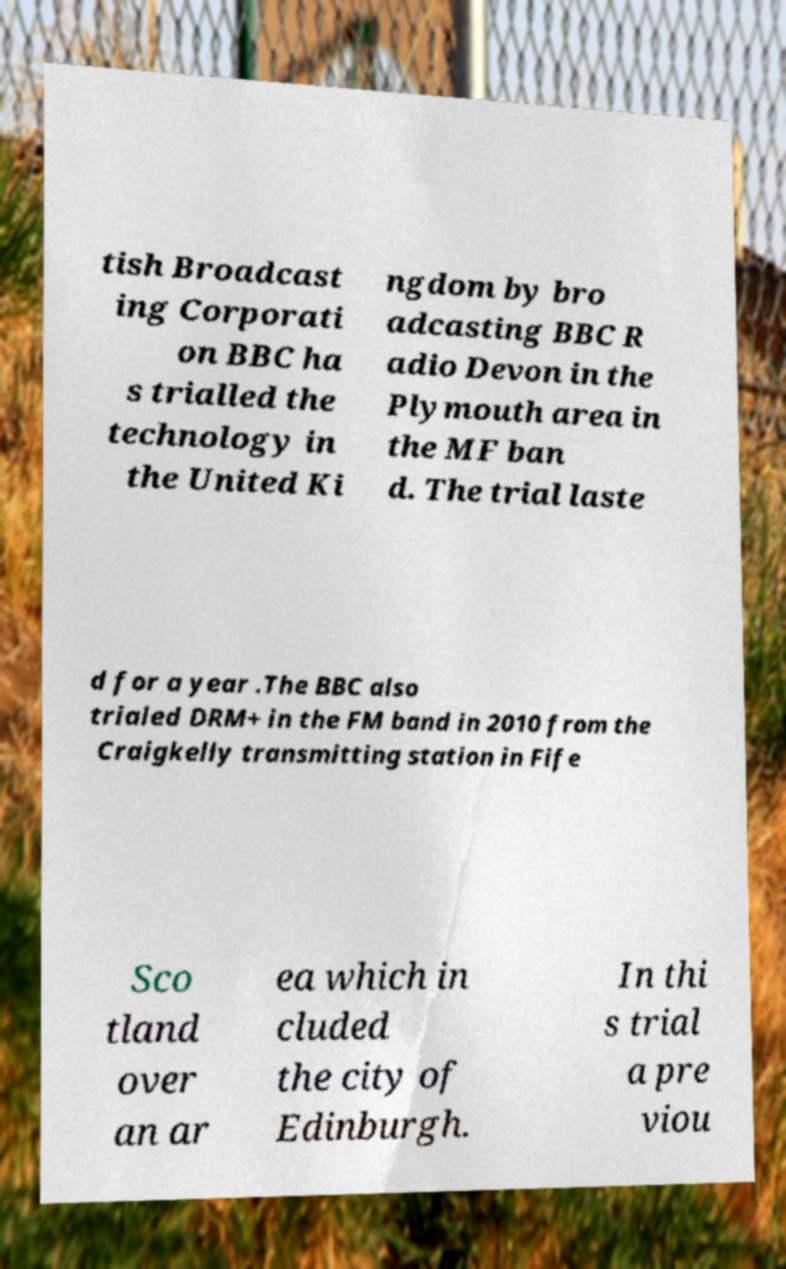What messages or text are displayed in this image? I need them in a readable, typed format. tish Broadcast ing Corporati on BBC ha s trialled the technology in the United Ki ngdom by bro adcasting BBC R adio Devon in the Plymouth area in the MF ban d. The trial laste d for a year .The BBC also trialed DRM+ in the FM band in 2010 from the Craigkelly transmitting station in Fife Sco tland over an ar ea which in cluded the city of Edinburgh. In thi s trial a pre viou 